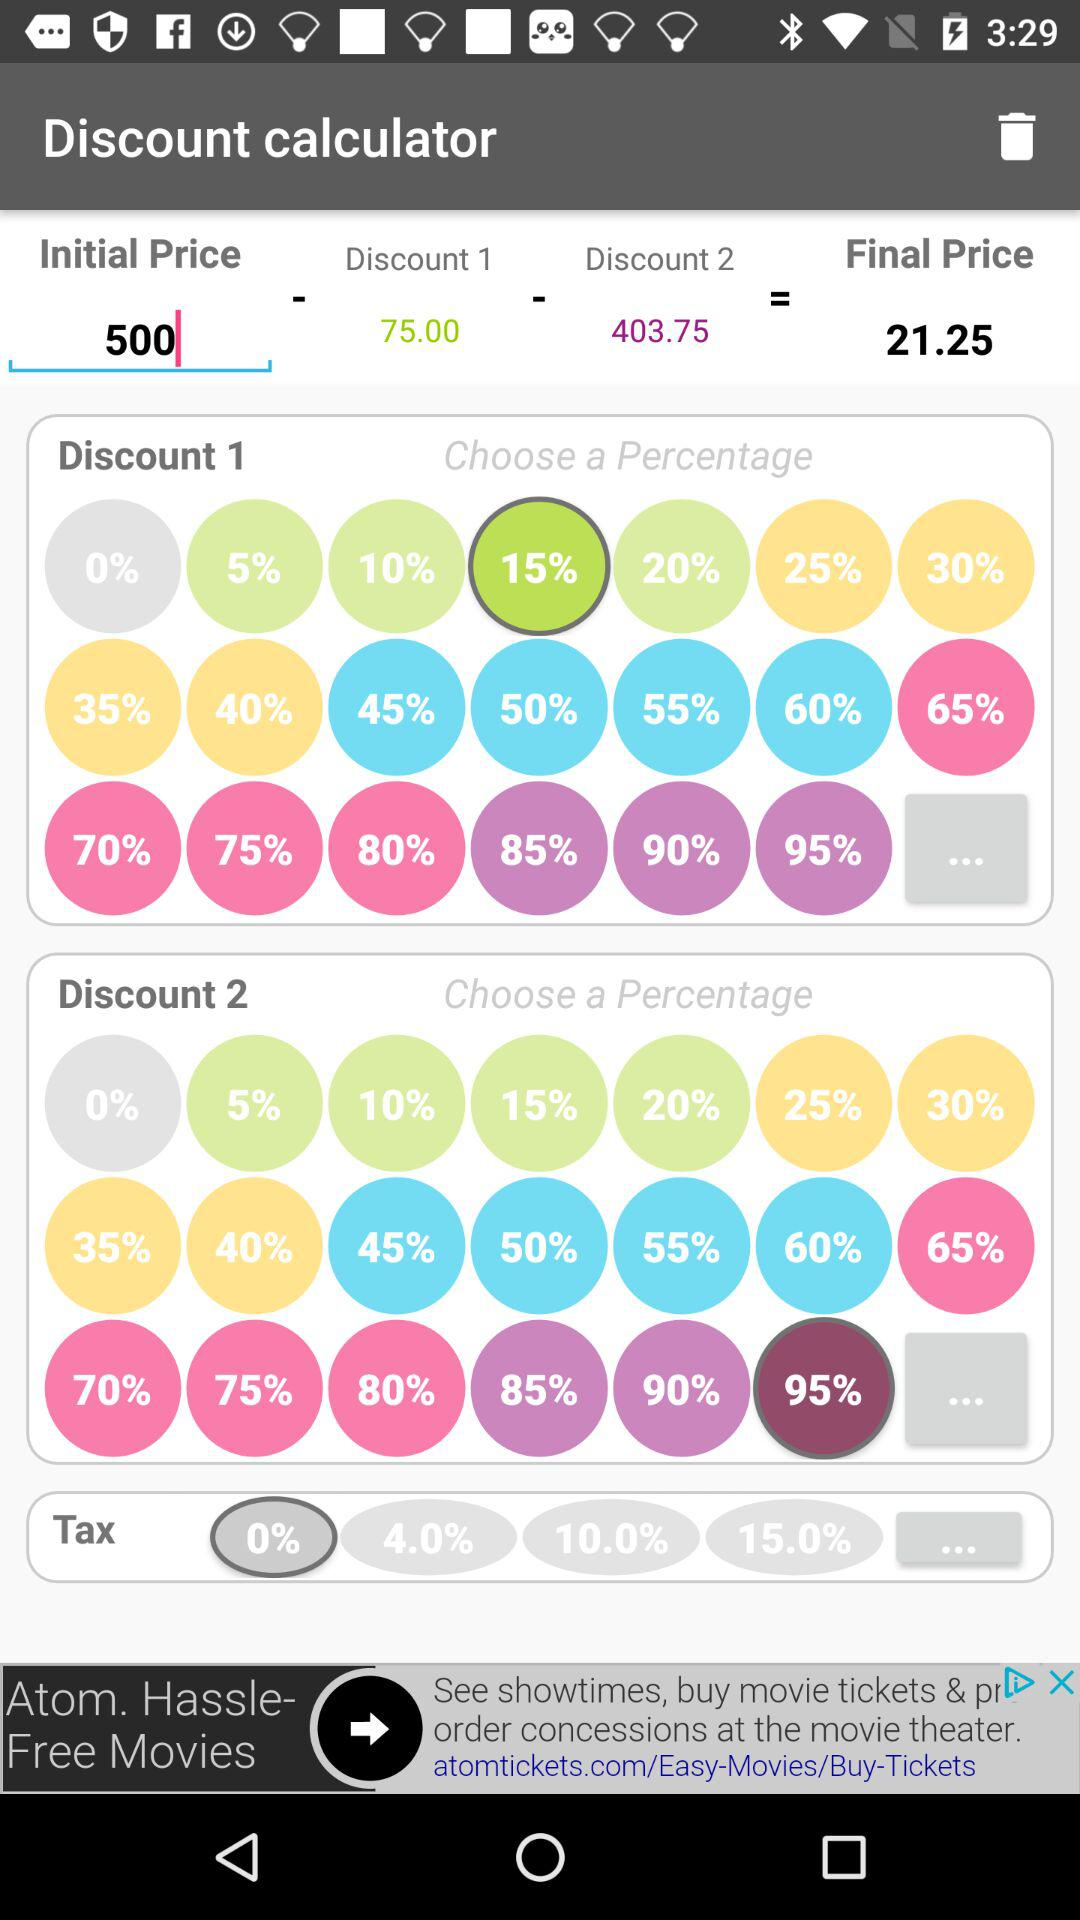How much is the tax percentage? The tax percentage is 0. 